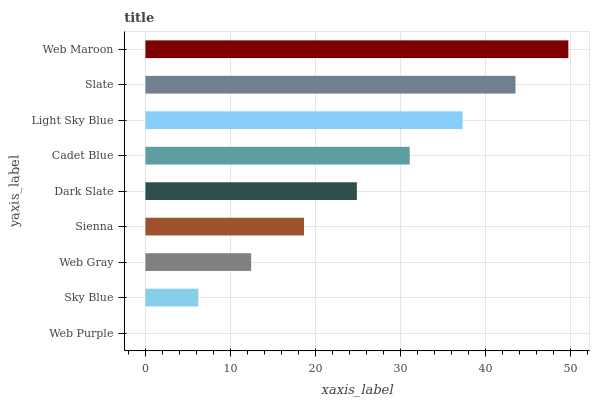Is Web Purple the minimum?
Answer yes or no. Yes. Is Web Maroon the maximum?
Answer yes or no. Yes. Is Sky Blue the minimum?
Answer yes or no. No. Is Sky Blue the maximum?
Answer yes or no. No. Is Sky Blue greater than Web Purple?
Answer yes or no. Yes. Is Web Purple less than Sky Blue?
Answer yes or no. Yes. Is Web Purple greater than Sky Blue?
Answer yes or no. No. Is Sky Blue less than Web Purple?
Answer yes or no. No. Is Dark Slate the high median?
Answer yes or no. Yes. Is Dark Slate the low median?
Answer yes or no. Yes. Is Web Maroon the high median?
Answer yes or no. No. Is Light Sky Blue the low median?
Answer yes or no. No. 